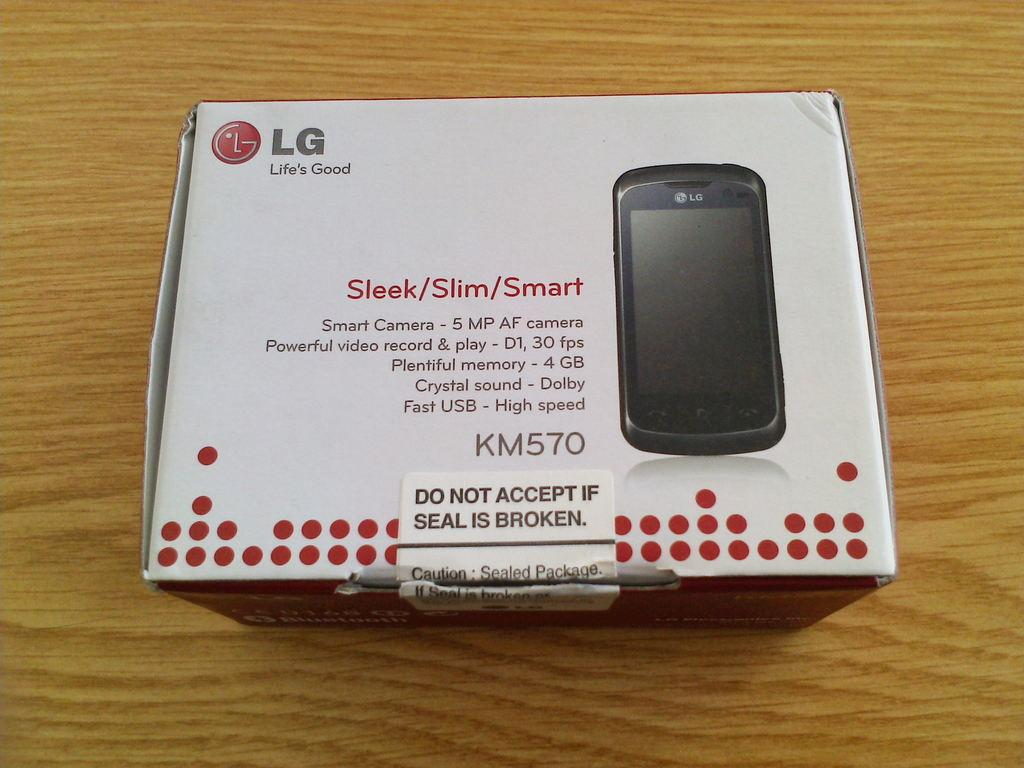<image>
Describe the image concisely. On a wood table sits an LG KM570 cell phone packaging box. 